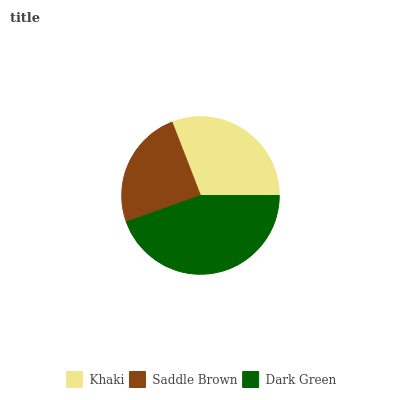Is Saddle Brown the minimum?
Answer yes or no. Yes. Is Dark Green the maximum?
Answer yes or no. Yes. Is Dark Green the minimum?
Answer yes or no. No. Is Saddle Brown the maximum?
Answer yes or no. No. Is Dark Green greater than Saddle Brown?
Answer yes or no. Yes. Is Saddle Brown less than Dark Green?
Answer yes or no. Yes. Is Saddle Brown greater than Dark Green?
Answer yes or no. No. Is Dark Green less than Saddle Brown?
Answer yes or no. No. Is Khaki the high median?
Answer yes or no. Yes. Is Khaki the low median?
Answer yes or no. Yes. Is Saddle Brown the high median?
Answer yes or no. No. Is Saddle Brown the low median?
Answer yes or no. No. 